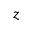<formula> <loc_0><loc_0><loc_500><loc_500>z</formula> 